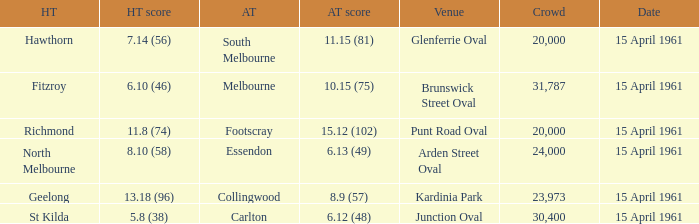What is the average crowd size when Collingwood is the away team? 23973.0. Could you parse the entire table? {'header': ['HT', 'HT score', 'AT', 'AT score', 'Venue', 'Crowd', 'Date'], 'rows': [['Hawthorn', '7.14 (56)', 'South Melbourne', '11.15 (81)', 'Glenferrie Oval', '20,000', '15 April 1961'], ['Fitzroy', '6.10 (46)', 'Melbourne', '10.15 (75)', 'Brunswick Street Oval', '31,787', '15 April 1961'], ['Richmond', '11.8 (74)', 'Footscray', '15.12 (102)', 'Punt Road Oval', '20,000', '15 April 1961'], ['North Melbourne', '8.10 (58)', 'Essendon', '6.13 (49)', 'Arden Street Oval', '24,000', '15 April 1961'], ['Geelong', '13.18 (96)', 'Collingwood', '8.9 (57)', 'Kardinia Park', '23,973', '15 April 1961'], ['St Kilda', '5.8 (38)', 'Carlton', '6.12 (48)', 'Junction Oval', '30,400', '15 April 1961']]} 